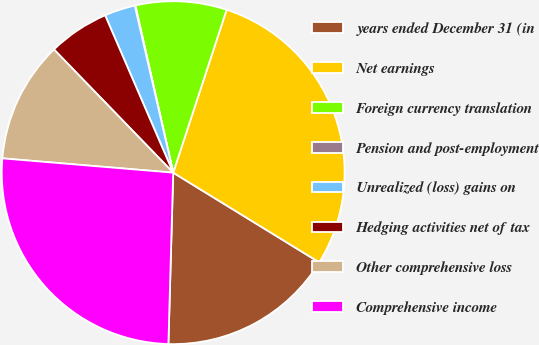<chart> <loc_0><loc_0><loc_500><loc_500><pie_chart><fcel>years ended December 31 (in<fcel>Net earnings<fcel>Foreign currency translation<fcel>Pension and post-employment<fcel>Unrealized (loss) gains on<fcel>Hedging activities net of tax<fcel>Other comprehensive loss<fcel>Comprehensive income<nl><fcel>16.68%<fcel>28.72%<fcel>8.58%<fcel>0.06%<fcel>2.9%<fcel>5.74%<fcel>11.43%<fcel>25.88%<nl></chart> 